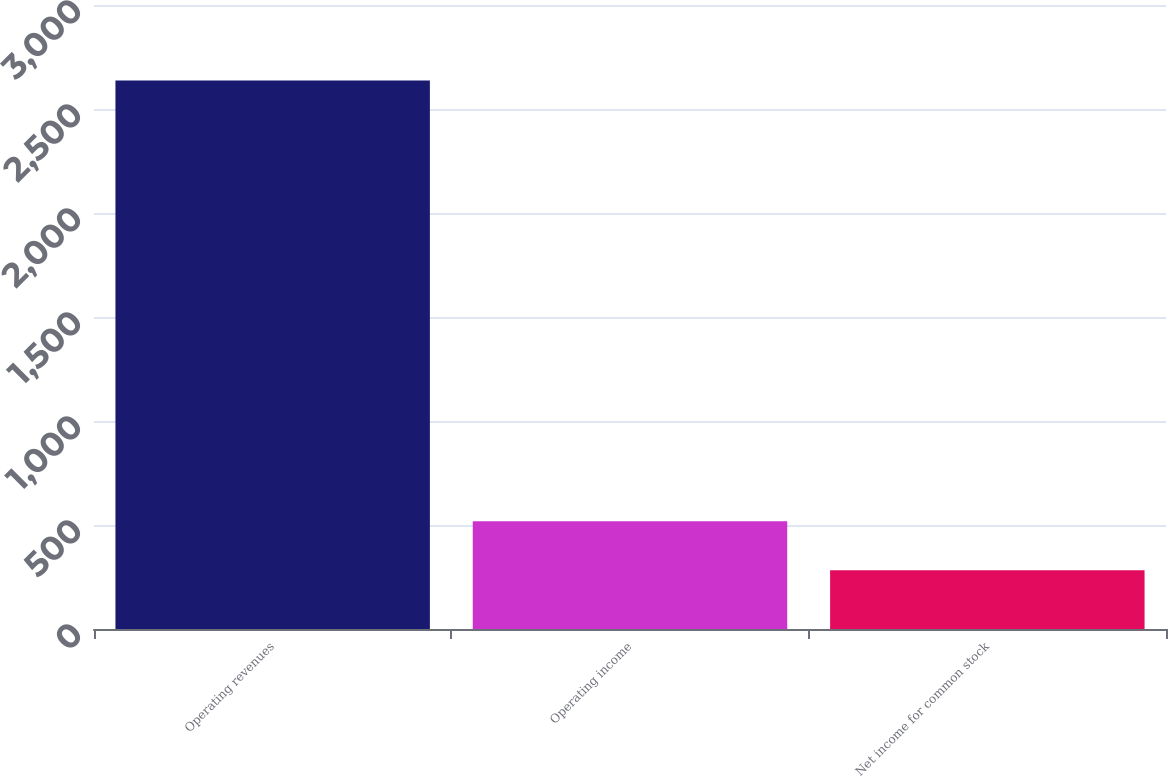Convert chart. <chart><loc_0><loc_0><loc_500><loc_500><bar_chart><fcel>Operating revenues<fcel>Operating income<fcel>Net income for common stock<nl><fcel>2637<fcel>517.5<fcel>282<nl></chart> 